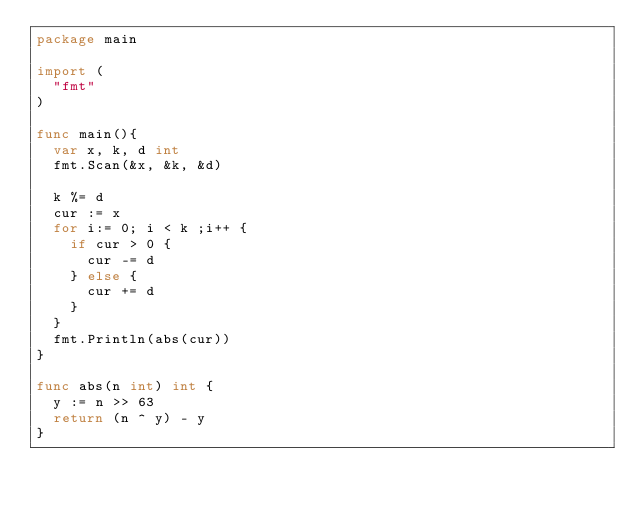<code> <loc_0><loc_0><loc_500><loc_500><_Go_>package main

import (
	"fmt"
)

func main(){
	var x, k, d int
	fmt.Scan(&x, &k, &d)

	k %= d
	cur := x
	for i:= 0; i < k ;i++ {
		if cur > 0 {
			cur -= d
		} else {
			cur += d
		}
	}
	fmt.Println(abs(cur))
}

func abs(n int) int {
	y := n >> 63
	return (n ^ y) - y
}
</code> 